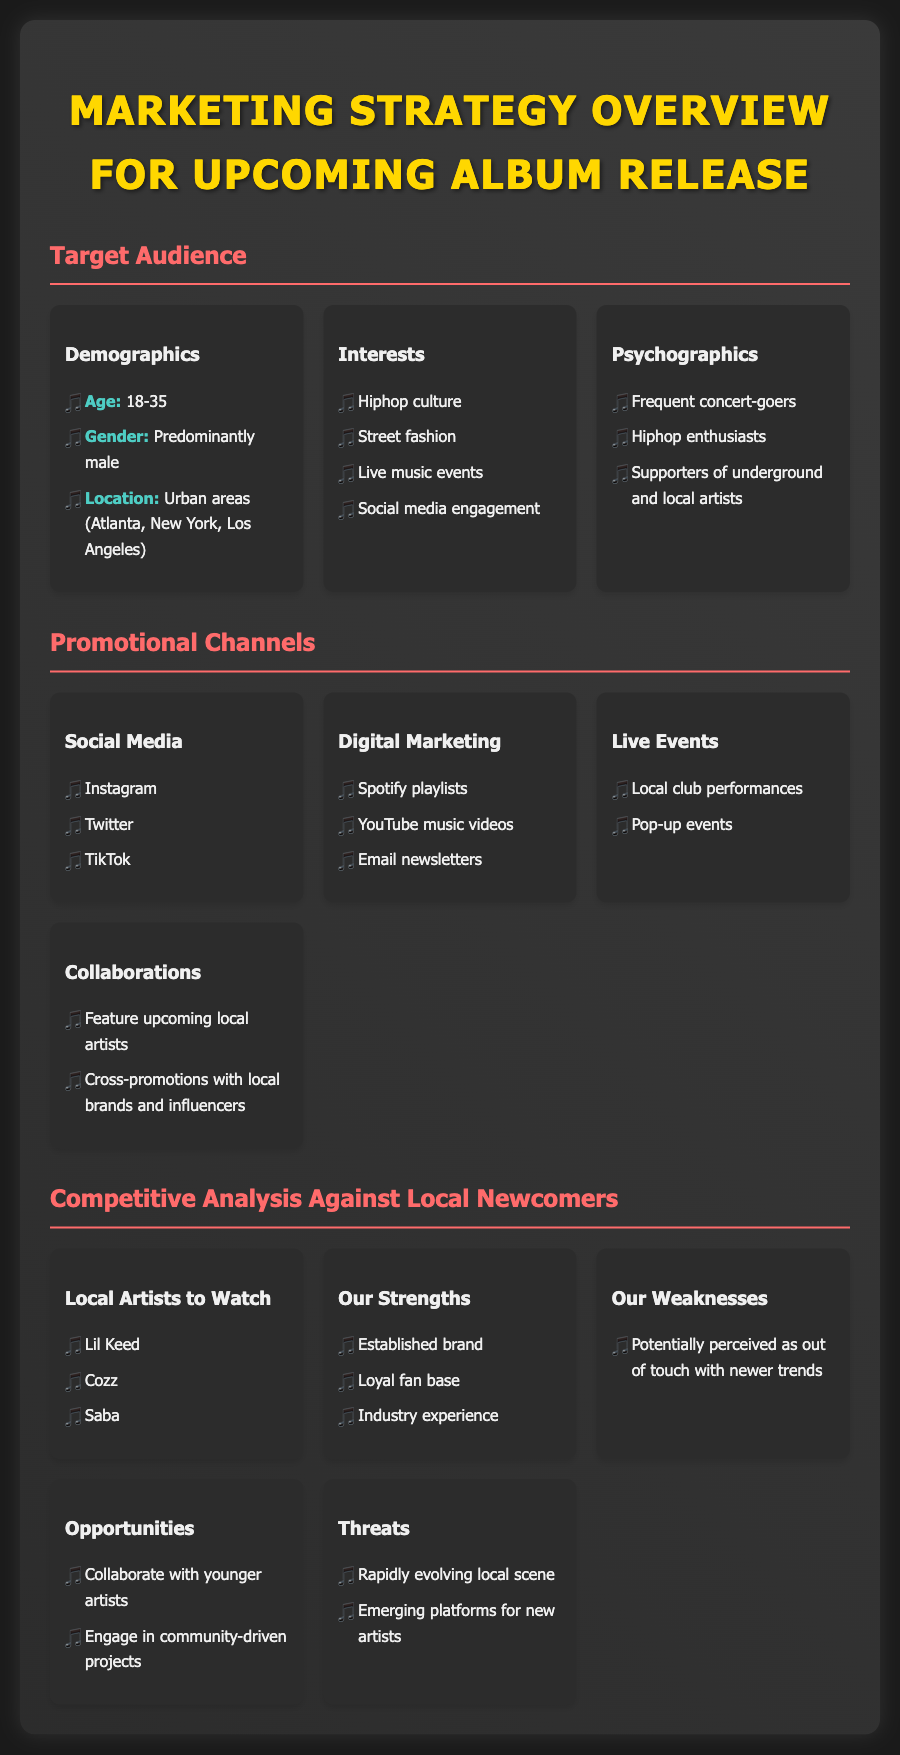What is the target age range for the audience? The target age range for the audience is specified in the demographics section under Target Audience, which states 18-35.
Answer: 18-35 Which promotional channel includes TikTok? TikTok is mentioned under the Social Media section of the Promotional Channels.
Answer: Social Media What local artists are mentioned as newcomers? The local artists to watch listed under Competitive Analysis Against Local Newcomers include Lil Keed, Cozz, and Saba.
Answer: Lil Keed, Cozz, Saba What is one of the identified weaknesses? The document lists a weakness under Our Weaknesses, stating that the brand may be perceived as out of touch with newer trends.
Answer: Potentially perceived as out of touch with newer trends What type of collaboration is suggested as an opportunity? The Opportunities section suggests collaborating with younger artists as a way to leverage market presence and foster innovation.
Answer: Collaborate with younger artists What is highlighted under Our Strengths? The document states that having an established brand is a strength, indicating the competitive advantage possessed.
Answer: Established brand Which demographic is predominantly targeted? The gender specified in the demographics section indicates that the targeted audience is predominantly male.
Answer: Predominantly male Which platforms are mentioned as emerging for new artists? Emerging platforms for new artists is noted under Threats in Competitive Analysis, indicating external challenges the established artist may face.
Answer: Emerging platforms for new artists What is emphasized as a common interest among the target audience? The common interest noted under Interests is hip hop culture, indicating a primary connection point for promotional efforts.
Answer: Hiphop culture 